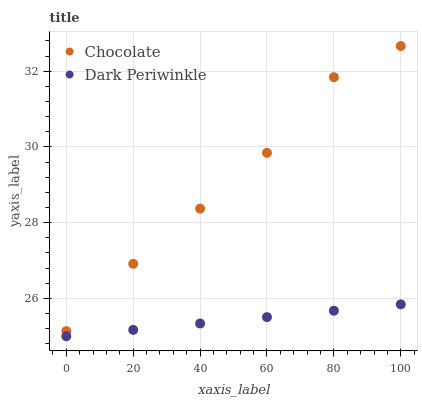Does Dark Periwinkle have the minimum area under the curve?
Answer yes or no. Yes. Does Chocolate have the maximum area under the curve?
Answer yes or no. Yes. Does Chocolate have the minimum area under the curve?
Answer yes or no. No. Is Dark Periwinkle the smoothest?
Answer yes or no. Yes. Is Chocolate the roughest?
Answer yes or no. Yes. Is Chocolate the smoothest?
Answer yes or no. No. Does Dark Periwinkle have the lowest value?
Answer yes or no. Yes. Does Chocolate have the lowest value?
Answer yes or no. No. Does Chocolate have the highest value?
Answer yes or no. Yes. Is Dark Periwinkle less than Chocolate?
Answer yes or no. Yes. Is Chocolate greater than Dark Periwinkle?
Answer yes or no. Yes. Does Dark Periwinkle intersect Chocolate?
Answer yes or no. No. 